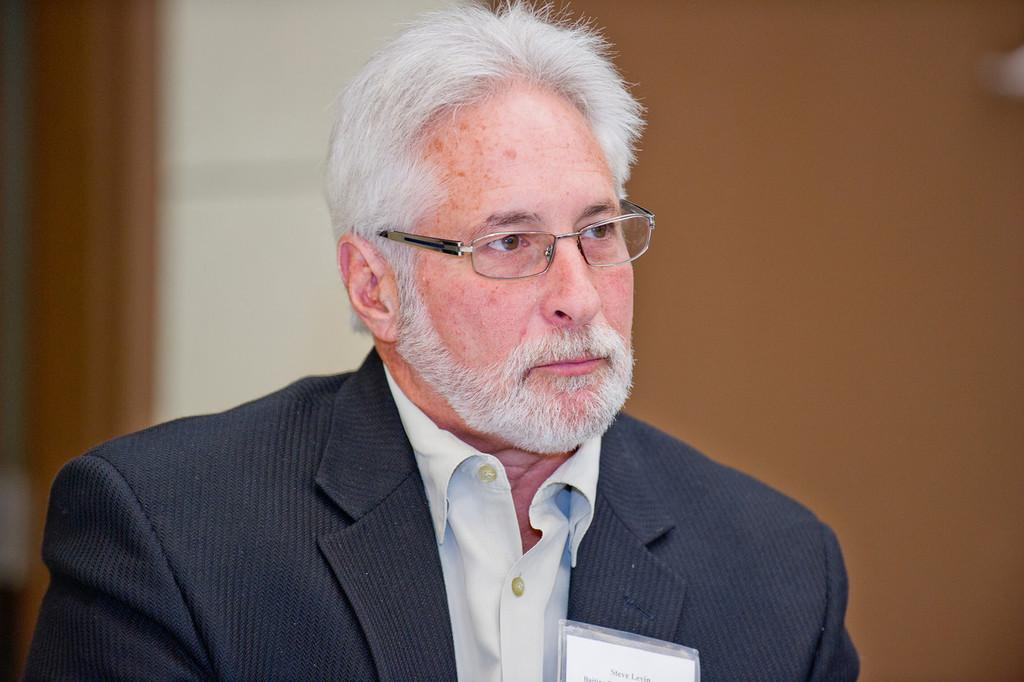Who is the main subject in the image? There is a man in the image. What is the man wearing? The man is wearing a suit. What accessory is the man wearing on his face? The man has spectacles. Can you describe the background of the image? The background of the image is blurred. What type of badge is the man wearing in the image? There is no badge visible on the man in the image. How does the man provide support to others in the image? The image does not depict the man providing support to others. 